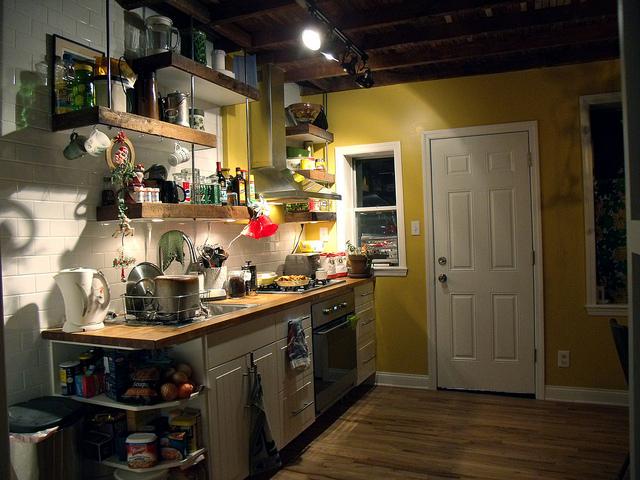What is hanging under the cabinet?
Give a very brief answer. Towel. Is this a galley-style kitchen?
Write a very short answer. No. What color is the door?
Concise answer only. White. Is this a home office?
Concise answer only. No. What color is the wall?
Give a very brief answer. Yellow. How many people live here?
Answer briefly. 4. Is it night time outside?
Keep it brief. Yes. Can I find out what time it is in this photo?
Write a very short answer. No. What is the red pump for?
Quick response, please. Light. 